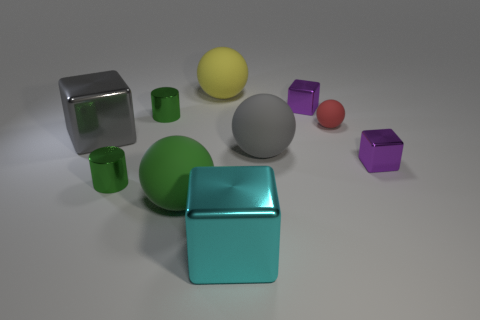Is the number of tiny things behind the big cyan metallic thing greater than the number of big gray shiny things?
Offer a terse response. Yes. Do the big object that is to the right of the cyan block and the small red matte object have the same shape?
Make the answer very short. Yes. Are there any cyan objects that have the same shape as the green rubber object?
Keep it short and to the point. No. How many things are tiny things in front of the gray rubber thing or purple matte objects?
Provide a short and direct response. 2. Is the number of big gray matte things greater than the number of large red rubber objects?
Make the answer very short. Yes. Are there any yellow matte objects of the same size as the gray matte sphere?
Offer a terse response. Yes. How many things are small green shiny cylinders that are in front of the gray ball or matte balls that are behind the big green rubber thing?
Your answer should be very brief. 4. There is a small ball right of the big block left of the big green thing; what is its color?
Make the answer very short. Red. The other large block that is made of the same material as the large cyan cube is what color?
Ensure brevity in your answer.  Gray. What number of things are small purple metallic blocks or large yellow balls?
Offer a terse response. 3. 